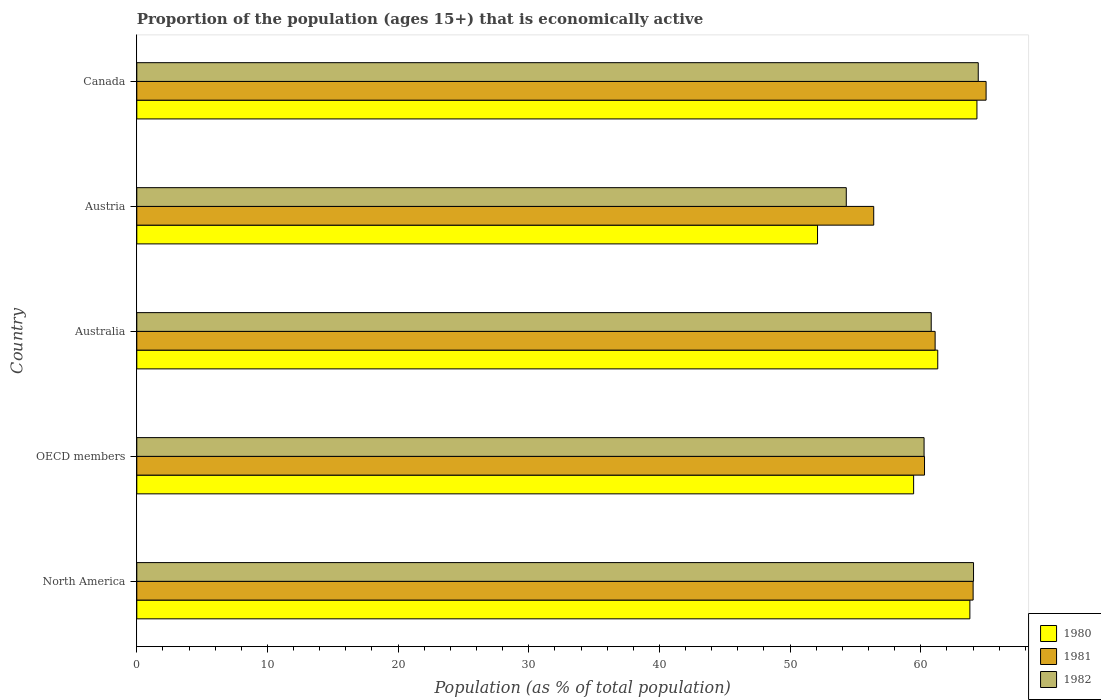How many different coloured bars are there?
Give a very brief answer. 3. How many bars are there on the 1st tick from the top?
Give a very brief answer. 3. What is the label of the 3rd group of bars from the top?
Your answer should be very brief. Australia. In how many cases, is the number of bars for a given country not equal to the number of legend labels?
Your answer should be compact. 0. What is the proportion of the population that is economically active in 1980 in OECD members?
Keep it short and to the point. 59.45. Across all countries, what is the maximum proportion of the population that is economically active in 1980?
Your answer should be compact. 64.3. Across all countries, what is the minimum proportion of the population that is economically active in 1980?
Give a very brief answer. 52.1. What is the total proportion of the population that is economically active in 1982 in the graph?
Provide a short and direct response. 303.79. What is the difference between the proportion of the population that is economically active in 1982 in North America and that in OECD members?
Your answer should be compact. 3.78. What is the difference between the proportion of the population that is economically active in 1980 in North America and the proportion of the population that is economically active in 1981 in OECD members?
Your answer should be compact. 3.47. What is the average proportion of the population that is economically active in 1982 per country?
Offer a terse response. 60.76. What is the difference between the proportion of the population that is economically active in 1982 and proportion of the population that is economically active in 1980 in Austria?
Offer a terse response. 2.2. In how many countries, is the proportion of the population that is economically active in 1982 greater than 66 %?
Keep it short and to the point. 0. What is the ratio of the proportion of the population that is economically active in 1981 in Austria to that in Canada?
Provide a succinct answer. 0.87. Is the proportion of the population that is economically active in 1981 in Austria less than that in OECD members?
Provide a succinct answer. Yes. What is the difference between the highest and the second highest proportion of the population that is economically active in 1980?
Ensure brevity in your answer.  0.54. What is the difference between the highest and the lowest proportion of the population that is economically active in 1981?
Ensure brevity in your answer.  8.6. Are all the bars in the graph horizontal?
Your answer should be very brief. Yes. What is the difference between two consecutive major ticks on the X-axis?
Your answer should be compact. 10. Are the values on the major ticks of X-axis written in scientific E-notation?
Offer a very short reply. No. Does the graph contain any zero values?
Your answer should be very brief. No. Does the graph contain grids?
Make the answer very short. No. How many legend labels are there?
Your response must be concise. 3. How are the legend labels stacked?
Keep it short and to the point. Vertical. What is the title of the graph?
Make the answer very short. Proportion of the population (ages 15+) that is economically active. Does "2007" appear as one of the legend labels in the graph?
Your answer should be compact. No. What is the label or title of the X-axis?
Offer a very short reply. Population (as % of total population). What is the Population (as % of total population) in 1980 in North America?
Your answer should be very brief. 63.76. What is the Population (as % of total population) of 1981 in North America?
Your answer should be compact. 64.01. What is the Population (as % of total population) of 1982 in North America?
Ensure brevity in your answer.  64.04. What is the Population (as % of total population) in 1980 in OECD members?
Keep it short and to the point. 59.45. What is the Population (as % of total population) of 1981 in OECD members?
Keep it short and to the point. 60.29. What is the Population (as % of total population) of 1982 in OECD members?
Keep it short and to the point. 60.25. What is the Population (as % of total population) in 1980 in Australia?
Ensure brevity in your answer.  61.3. What is the Population (as % of total population) of 1981 in Australia?
Ensure brevity in your answer.  61.1. What is the Population (as % of total population) in 1982 in Australia?
Your answer should be very brief. 60.8. What is the Population (as % of total population) in 1980 in Austria?
Your answer should be compact. 52.1. What is the Population (as % of total population) in 1981 in Austria?
Give a very brief answer. 56.4. What is the Population (as % of total population) of 1982 in Austria?
Offer a very short reply. 54.3. What is the Population (as % of total population) in 1980 in Canada?
Offer a terse response. 64.3. What is the Population (as % of total population) in 1982 in Canada?
Your answer should be very brief. 64.4. Across all countries, what is the maximum Population (as % of total population) of 1980?
Give a very brief answer. 64.3. Across all countries, what is the maximum Population (as % of total population) in 1981?
Give a very brief answer. 65. Across all countries, what is the maximum Population (as % of total population) of 1982?
Ensure brevity in your answer.  64.4. Across all countries, what is the minimum Population (as % of total population) of 1980?
Your answer should be very brief. 52.1. Across all countries, what is the minimum Population (as % of total population) of 1981?
Offer a very short reply. 56.4. Across all countries, what is the minimum Population (as % of total population) of 1982?
Keep it short and to the point. 54.3. What is the total Population (as % of total population) in 1980 in the graph?
Your answer should be very brief. 300.91. What is the total Population (as % of total population) of 1981 in the graph?
Offer a terse response. 306.79. What is the total Population (as % of total population) of 1982 in the graph?
Your answer should be compact. 303.79. What is the difference between the Population (as % of total population) of 1980 in North America and that in OECD members?
Your answer should be very brief. 4.3. What is the difference between the Population (as % of total population) of 1981 in North America and that in OECD members?
Offer a very short reply. 3.72. What is the difference between the Population (as % of total population) of 1982 in North America and that in OECD members?
Ensure brevity in your answer.  3.78. What is the difference between the Population (as % of total population) of 1980 in North America and that in Australia?
Your answer should be compact. 2.46. What is the difference between the Population (as % of total population) in 1981 in North America and that in Australia?
Keep it short and to the point. 2.91. What is the difference between the Population (as % of total population) in 1982 in North America and that in Australia?
Your answer should be very brief. 3.24. What is the difference between the Population (as % of total population) in 1980 in North America and that in Austria?
Give a very brief answer. 11.66. What is the difference between the Population (as % of total population) of 1981 in North America and that in Austria?
Keep it short and to the point. 7.61. What is the difference between the Population (as % of total population) of 1982 in North America and that in Austria?
Ensure brevity in your answer.  9.74. What is the difference between the Population (as % of total population) in 1980 in North America and that in Canada?
Offer a very short reply. -0.54. What is the difference between the Population (as % of total population) of 1981 in North America and that in Canada?
Offer a very short reply. -0.99. What is the difference between the Population (as % of total population) in 1982 in North America and that in Canada?
Offer a terse response. -0.36. What is the difference between the Population (as % of total population) of 1980 in OECD members and that in Australia?
Provide a short and direct response. -1.85. What is the difference between the Population (as % of total population) in 1981 in OECD members and that in Australia?
Your response must be concise. -0.81. What is the difference between the Population (as % of total population) of 1982 in OECD members and that in Australia?
Offer a terse response. -0.55. What is the difference between the Population (as % of total population) in 1980 in OECD members and that in Austria?
Provide a succinct answer. 7.35. What is the difference between the Population (as % of total population) of 1981 in OECD members and that in Austria?
Provide a short and direct response. 3.89. What is the difference between the Population (as % of total population) in 1982 in OECD members and that in Austria?
Ensure brevity in your answer.  5.95. What is the difference between the Population (as % of total population) in 1980 in OECD members and that in Canada?
Offer a very short reply. -4.85. What is the difference between the Population (as % of total population) of 1981 in OECD members and that in Canada?
Your answer should be compact. -4.71. What is the difference between the Population (as % of total population) of 1982 in OECD members and that in Canada?
Your answer should be compact. -4.15. What is the difference between the Population (as % of total population) in 1982 in Australia and that in Austria?
Ensure brevity in your answer.  6.5. What is the difference between the Population (as % of total population) of 1980 in Australia and that in Canada?
Provide a succinct answer. -3. What is the difference between the Population (as % of total population) in 1981 in Austria and that in Canada?
Your answer should be compact. -8.6. What is the difference between the Population (as % of total population) in 1980 in North America and the Population (as % of total population) in 1981 in OECD members?
Your answer should be very brief. 3.47. What is the difference between the Population (as % of total population) of 1980 in North America and the Population (as % of total population) of 1982 in OECD members?
Offer a very short reply. 3.5. What is the difference between the Population (as % of total population) of 1981 in North America and the Population (as % of total population) of 1982 in OECD members?
Give a very brief answer. 3.75. What is the difference between the Population (as % of total population) of 1980 in North America and the Population (as % of total population) of 1981 in Australia?
Provide a short and direct response. 2.66. What is the difference between the Population (as % of total population) of 1980 in North America and the Population (as % of total population) of 1982 in Australia?
Offer a very short reply. 2.96. What is the difference between the Population (as % of total population) in 1981 in North America and the Population (as % of total population) in 1982 in Australia?
Your response must be concise. 3.21. What is the difference between the Population (as % of total population) in 1980 in North America and the Population (as % of total population) in 1981 in Austria?
Your answer should be compact. 7.36. What is the difference between the Population (as % of total population) in 1980 in North America and the Population (as % of total population) in 1982 in Austria?
Your response must be concise. 9.46. What is the difference between the Population (as % of total population) of 1981 in North America and the Population (as % of total population) of 1982 in Austria?
Your answer should be compact. 9.71. What is the difference between the Population (as % of total population) of 1980 in North America and the Population (as % of total population) of 1981 in Canada?
Your answer should be very brief. -1.24. What is the difference between the Population (as % of total population) of 1980 in North America and the Population (as % of total population) of 1982 in Canada?
Your answer should be compact. -0.64. What is the difference between the Population (as % of total population) of 1981 in North America and the Population (as % of total population) of 1982 in Canada?
Your answer should be very brief. -0.39. What is the difference between the Population (as % of total population) in 1980 in OECD members and the Population (as % of total population) in 1981 in Australia?
Your response must be concise. -1.65. What is the difference between the Population (as % of total population) of 1980 in OECD members and the Population (as % of total population) of 1982 in Australia?
Offer a very short reply. -1.35. What is the difference between the Population (as % of total population) of 1981 in OECD members and the Population (as % of total population) of 1982 in Australia?
Make the answer very short. -0.51. What is the difference between the Population (as % of total population) of 1980 in OECD members and the Population (as % of total population) of 1981 in Austria?
Offer a terse response. 3.05. What is the difference between the Population (as % of total population) of 1980 in OECD members and the Population (as % of total population) of 1982 in Austria?
Your answer should be compact. 5.15. What is the difference between the Population (as % of total population) in 1981 in OECD members and the Population (as % of total population) in 1982 in Austria?
Provide a short and direct response. 5.99. What is the difference between the Population (as % of total population) of 1980 in OECD members and the Population (as % of total population) of 1981 in Canada?
Give a very brief answer. -5.55. What is the difference between the Population (as % of total population) of 1980 in OECD members and the Population (as % of total population) of 1982 in Canada?
Ensure brevity in your answer.  -4.95. What is the difference between the Population (as % of total population) in 1981 in OECD members and the Population (as % of total population) in 1982 in Canada?
Your answer should be compact. -4.11. What is the difference between the Population (as % of total population) in 1980 in Australia and the Population (as % of total population) in 1982 in Austria?
Offer a terse response. 7. What is the difference between the Population (as % of total population) of 1981 in Australia and the Population (as % of total population) of 1982 in Austria?
Give a very brief answer. 6.8. What is the difference between the Population (as % of total population) of 1980 in Australia and the Population (as % of total population) of 1981 in Canada?
Offer a terse response. -3.7. What is the difference between the Population (as % of total population) of 1980 in Austria and the Population (as % of total population) of 1982 in Canada?
Ensure brevity in your answer.  -12.3. What is the average Population (as % of total population) in 1980 per country?
Keep it short and to the point. 60.18. What is the average Population (as % of total population) of 1981 per country?
Give a very brief answer. 61.36. What is the average Population (as % of total population) in 1982 per country?
Provide a succinct answer. 60.76. What is the difference between the Population (as % of total population) of 1980 and Population (as % of total population) of 1981 in North America?
Ensure brevity in your answer.  -0.25. What is the difference between the Population (as % of total population) in 1980 and Population (as % of total population) in 1982 in North America?
Make the answer very short. -0.28. What is the difference between the Population (as % of total population) of 1981 and Population (as % of total population) of 1982 in North America?
Keep it short and to the point. -0.03. What is the difference between the Population (as % of total population) in 1980 and Population (as % of total population) in 1981 in OECD members?
Provide a short and direct response. -0.83. What is the difference between the Population (as % of total population) of 1980 and Population (as % of total population) of 1982 in OECD members?
Your answer should be compact. -0.8. What is the difference between the Population (as % of total population) in 1981 and Population (as % of total population) in 1982 in OECD members?
Offer a very short reply. 0.03. What is the difference between the Population (as % of total population) of 1980 and Population (as % of total population) of 1981 in Australia?
Provide a succinct answer. 0.2. What is the difference between the Population (as % of total population) of 1980 and Population (as % of total population) of 1982 in Australia?
Your answer should be compact. 0.5. What is the difference between the Population (as % of total population) in 1981 and Population (as % of total population) in 1982 in Australia?
Ensure brevity in your answer.  0.3. What is the difference between the Population (as % of total population) in 1980 and Population (as % of total population) in 1981 in Austria?
Your answer should be compact. -4.3. What is the difference between the Population (as % of total population) in 1980 and Population (as % of total population) in 1982 in Austria?
Give a very brief answer. -2.2. What is the difference between the Population (as % of total population) in 1981 and Population (as % of total population) in 1982 in Austria?
Make the answer very short. 2.1. What is the difference between the Population (as % of total population) in 1980 and Population (as % of total population) in 1981 in Canada?
Keep it short and to the point. -0.7. What is the difference between the Population (as % of total population) in 1980 and Population (as % of total population) in 1982 in Canada?
Keep it short and to the point. -0.1. What is the difference between the Population (as % of total population) of 1981 and Population (as % of total population) of 1982 in Canada?
Make the answer very short. 0.6. What is the ratio of the Population (as % of total population) in 1980 in North America to that in OECD members?
Offer a very short reply. 1.07. What is the ratio of the Population (as % of total population) of 1981 in North America to that in OECD members?
Provide a short and direct response. 1.06. What is the ratio of the Population (as % of total population) in 1982 in North America to that in OECD members?
Your response must be concise. 1.06. What is the ratio of the Population (as % of total population) in 1980 in North America to that in Australia?
Ensure brevity in your answer.  1.04. What is the ratio of the Population (as % of total population) in 1981 in North America to that in Australia?
Keep it short and to the point. 1.05. What is the ratio of the Population (as % of total population) in 1982 in North America to that in Australia?
Make the answer very short. 1.05. What is the ratio of the Population (as % of total population) of 1980 in North America to that in Austria?
Keep it short and to the point. 1.22. What is the ratio of the Population (as % of total population) of 1981 in North America to that in Austria?
Your answer should be compact. 1.13. What is the ratio of the Population (as % of total population) of 1982 in North America to that in Austria?
Ensure brevity in your answer.  1.18. What is the ratio of the Population (as % of total population) of 1980 in North America to that in Canada?
Offer a terse response. 0.99. What is the ratio of the Population (as % of total population) of 1981 in North America to that in Canada?
Your answer should be compact. 0.98. What is the ratio of the Population (as % of total population) in 1982 in North America to that in Canada?
Ensure brevity in your answer.  0.99. What is the ratio of the Population (as % of total population) of 1980 in OECD members to that in Australia?
Offer a terse response. 0.97. What is the ratio of the Population (as % of total population) of 1981 in OECD members to that in Australia?
Offer a very short reply. 0.99. What is the ratio of the Population (as % of total population) of 1982 in OECD members to that in Australia?
Ensure brevity in your answer.  0.99. What is the ratio of the Population (as % of total population) of 1980 in OECD members to that in Austria?
Your answer should be compact. 1.14. What is the ratio of the Population (as % of total population) in 1981 in OECD members to that in Austria?
Your answer should be compact. 1.07. What is the ratio of the Population (as % of total population) of 1982 in OECD members to that in Austria?
Give a very brief answer. 1.11. What is the ratio of the Population (as % of total population) of 1980 in OECD members to that in Canada?
Keep it short and to the point. 0.92. What is the ratio of the Population (as % of total population) of 1981 in OECD members to that in Canada?
Your answer should be very brief. 0.93. What is the ratio of the Population (as % of total population) of 1982 in OECD members to that in Canada?
Offer a very short reply. 0.94. What is the ratio of the Population (as % of total population) in 1980 in Australia to that in Austria?
Make the answer very short. 1.18. What is the ratio of the Population (as % of total population) of 1982 in Australia to that in Austria?
Provide a short and direct response. 1.12. What is the ratio of the Population (as % of total population) in 1980 in Australia to that in Canada?
Offer a very short reply. 0.95. What is the ratio of the Population (as % of total population) in 1981 in Australia to that in Canada?
Give a very brief answer. 0.94. What is the ratio of the Population (as % of total population) in 1982 in Australia to that in Canada?
Your response must be concise. 0.94. What is the ratio of the Population (as % of total population) in 1980 in Austria to that in Canada?
Keep it short and to the point. 0.81. What is the ratio of the Population (as % of total population) in 1981 in Austria to that in Canada?
Ensure brevity in your answer.  0.87. What is the ratio of the Population (as % of total population) of 1982 in Austria to that in Canada?
Give a very brief answer. 0.84. What is the difference between the highest and the second highest Population (as % of total population) in 1980?
Make the answer very short. 0.54. What is the difference between the highest and the second highest Population (as % of total population) of 1981?
Give a very brief answer. 0.99. What is the difference between the highest and the second highest Population (as % of total population) in 1982?
Offer a terse response. 0.36. 